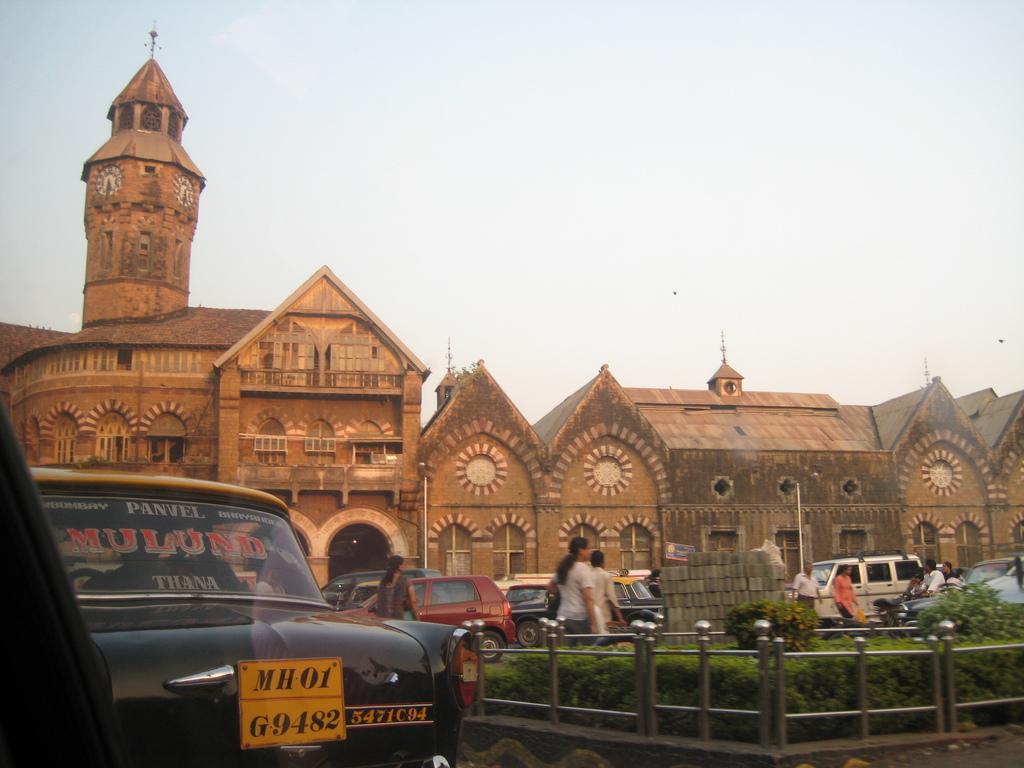Can you describe this image briefly? In the foreground of this image, there is a car, railing and plants. In the background, there are bricks,vehicles, persons moving on the road, building and the sky. 